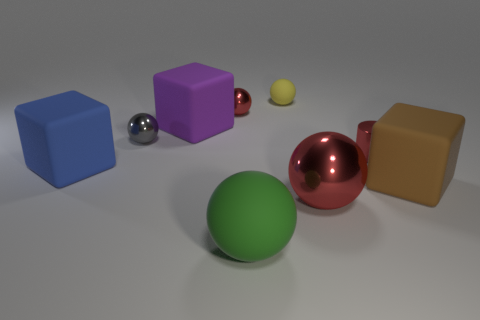Are there any other things that have the same shape as the purple rubber thing?
Provide a succinct answer. Yes. Is the number of cubes that are to the left of the small gray sphere greater than the number of blue matte cylinders?
Your answer should be compact. Yes. How many large rubber blocks are in front of the large rubber sphere that is right of the small gray metallic sphere?
Your response must be concise. 0. The large object behind the small metallic thing to the right of the red ball that is on the left side of the green object is what shape?
Your answer should be very brief. Cube. What size is the blue matte object?
Keep it short and to the point. Large. Are there any green blocks made of the same material as the big red sphere?
Offer a terse response. No. The brown object that is the same shape as the big purple thing is what size?
Make the answer very short. Large. Are there an equal number of cubes in front of the purple matte object and tiny yellow rubber spheres?
Offer a very short reply. No. There is a large object behind the big blue matte thing; is it the same shape as the big green object?
Provide a short and direct response. No. What is the shape of the tiny gray thing?
Ensure brevity in your answer.  Sphere. 